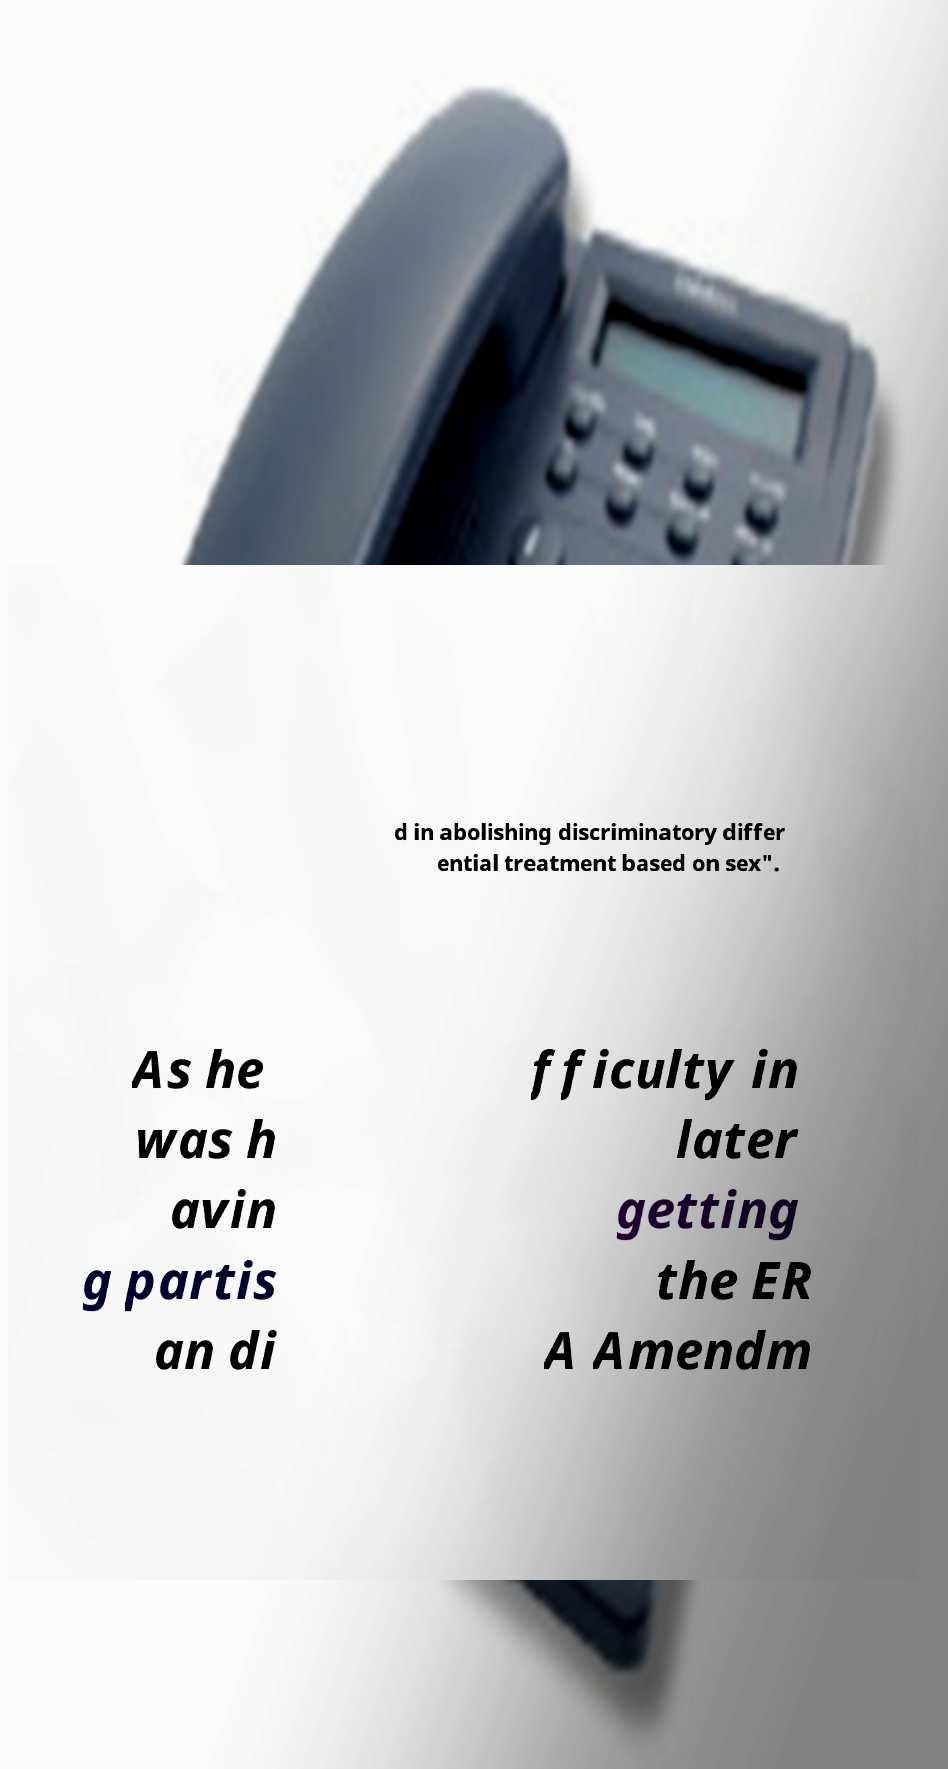Could you extract and type out the text from this image? d in abolishing discriminatory differ ential treatment based on sex". As he was h avin g partis an di fficulty in later getting the ER A Amendm 